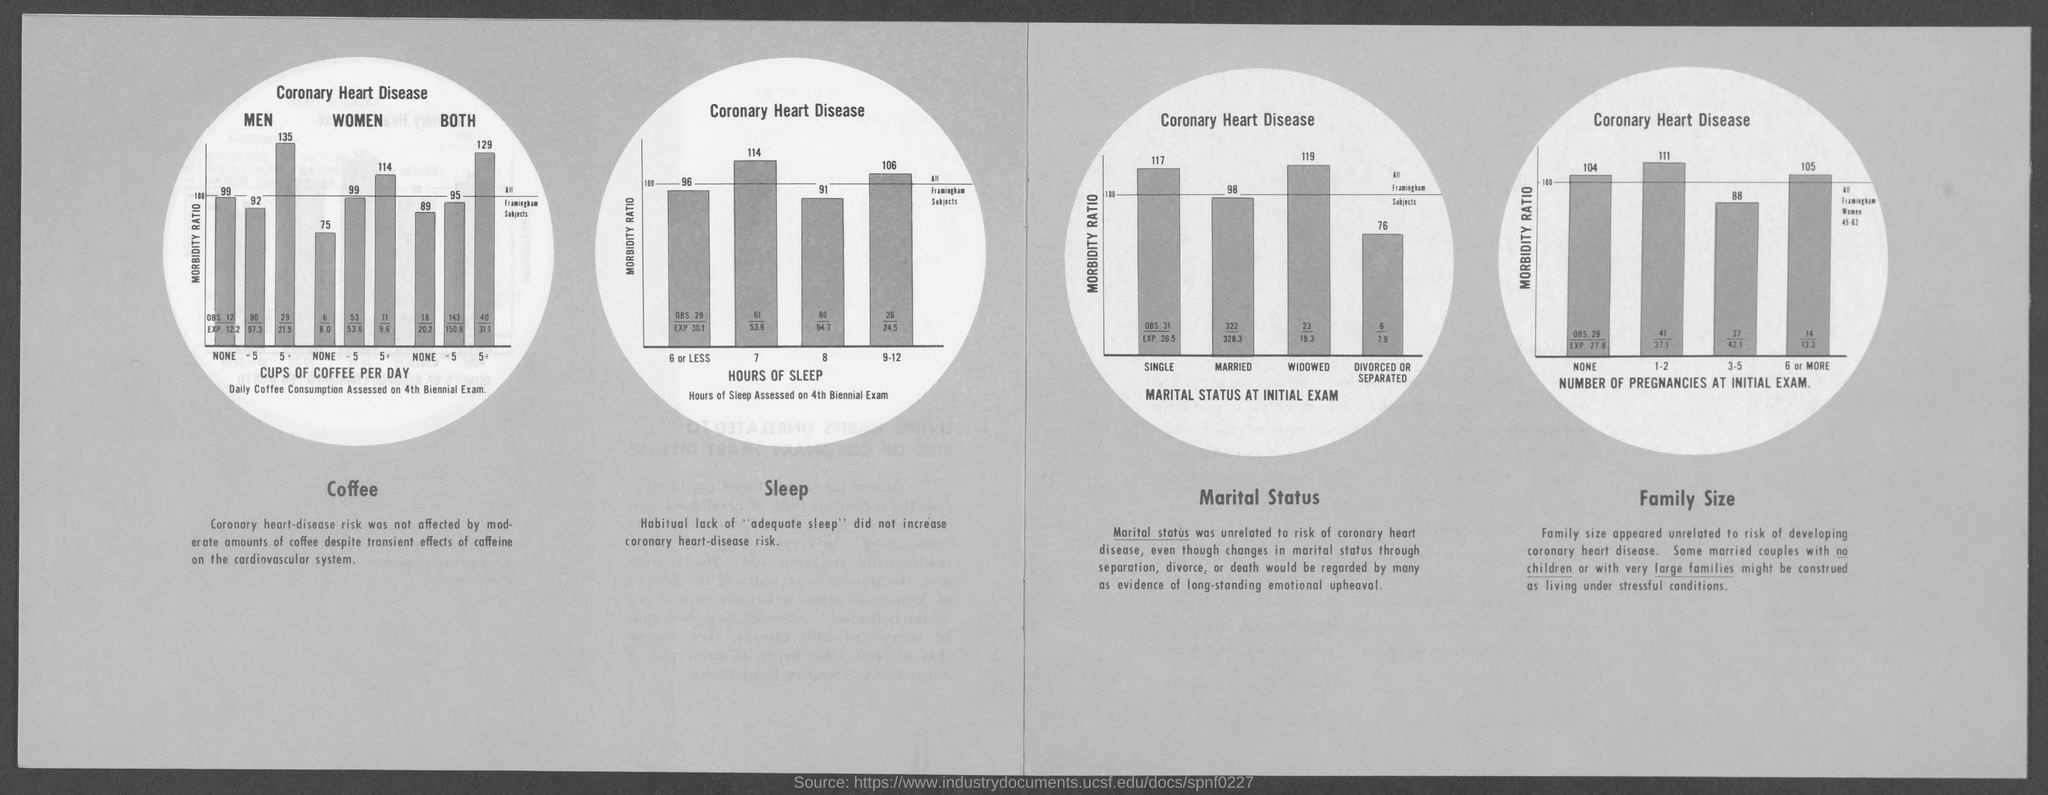Give some essential details in this illustration. The number of pregnancies at the initial examination is on the x-axis of the fourth bar chart. The second bar chart displays the number of hours of sleep for each age group. The first bar chart shows the amount of cups of coffee consumed per day, with the x-axis indicating the different levels of consumption. The third bar chart shows the distribution of marital status of individuals who took an initial examination, with "MARITAL STATUS AT INITIAL EXAM" listed on the X-axis. 